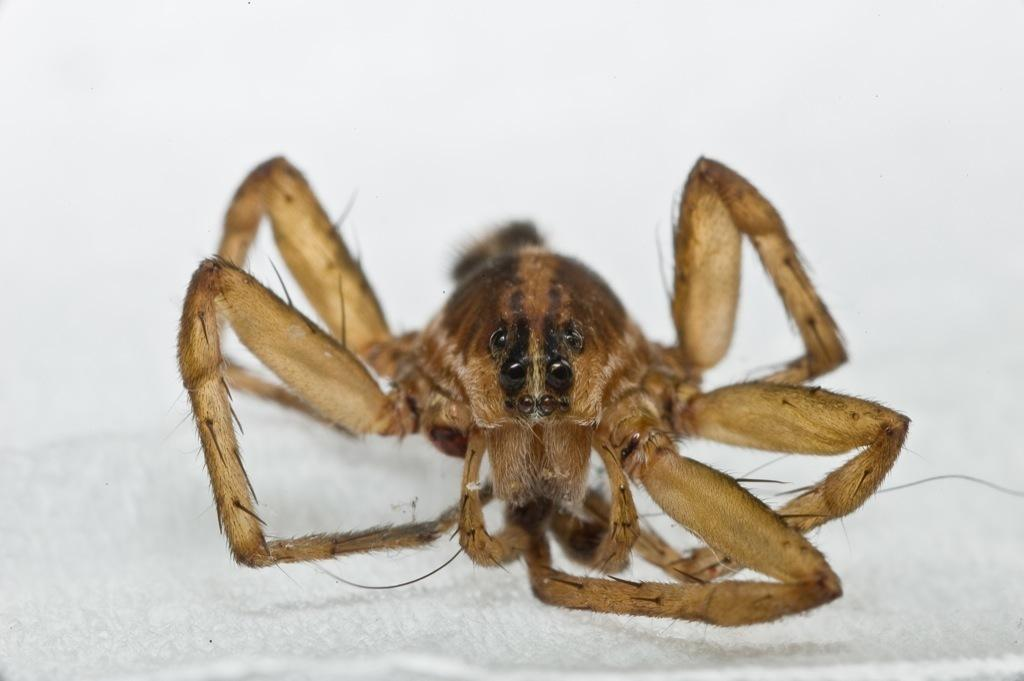What is present on the white surface in the image? There is an insect on the white surface in the image. Can you describe the insect's location on the white surface? The insect is on the white surface in the image. What type of quiver is the insect using to store its arrows in the image? There is no quiver or arrows present in the image; it features an insect on a white surface. 